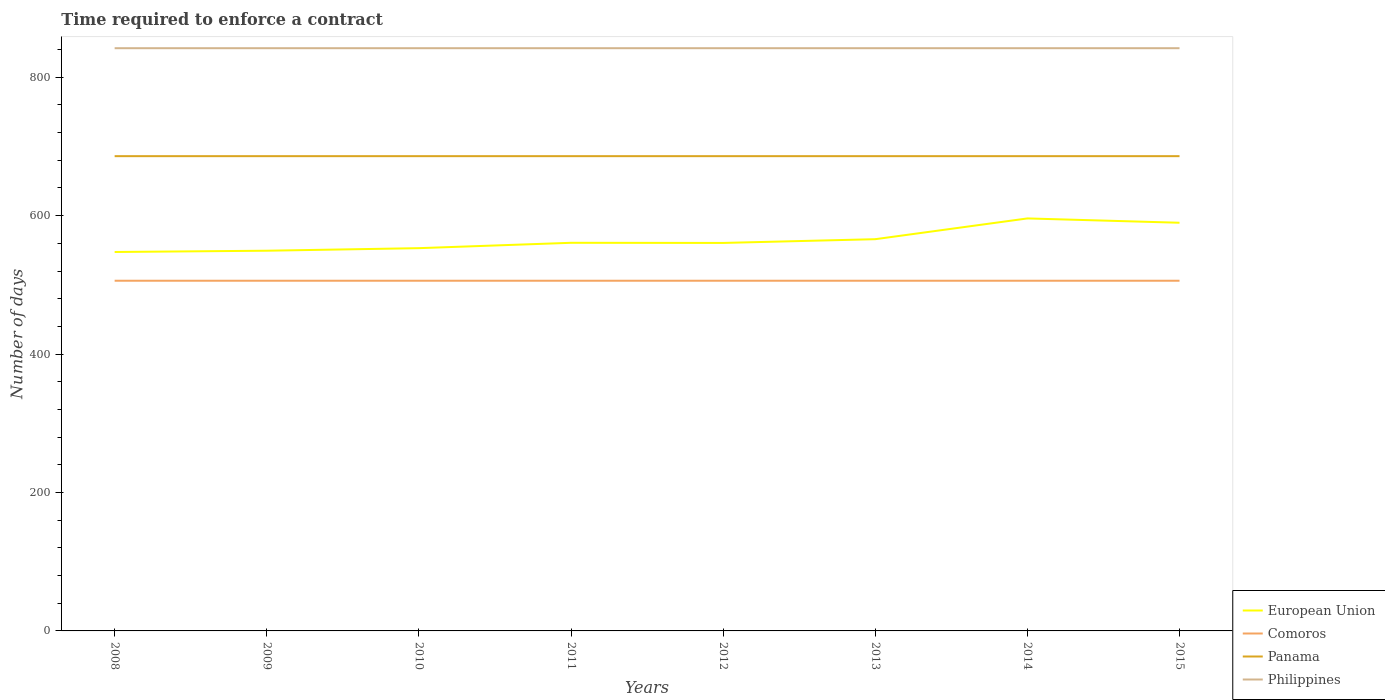Is the number of lines equal to the number of legend labels?
Your answer should be very brief. Yes. Across all years, what is the maximum number of days required to enforce a contract in Philippines?
Your answer should be very brief. 842. What is the total number of days required to enforce a contract in Panama in the graph?
Provide a short and direct response. 0. How many years are there in the graph?
Your answer should be very brief. 8. What is the difference between two consecutive major ticks on the Y-axis?
Ensure brevity in your answer.  200. Are the values on the major ticks of Y-axis written in scientific E-notation?
Ensure brevity in your answer.  No. Where does the legend appear in the graph?
Make the answer very short. Bottom right. How many legend labels are there?
Give a very brief answer. 4. How are the legend labels stacked?
Provide a succinct answer. Vertical. What is the title of the graph?
Provide a succinct answer. Time required to enforce a contract. What is the label or title of the X-axis?
Your response must be concise. Years. What is the label or title of the Y-axis?
Provide a succinct answer. Number of days. What is the Number of days of European Union in 2008?
Your answer should be compact. 547.56. What is the Number of days in Comoros in 2008?
Keep it short and to the point. 506. What is the Number of days in Panama in 2008?
Give a very brief answer. 686. What is the Number of days of Philippines in 2008?
Provide a succinct answer. 842. What is the Number of days of European Union in 2009?
Make the answer very short. 549.37. What is the Number of days of Comoros in 2009?
Your answer should be compact. 506. What is the Number of days in Panama in 2009?
Your response must be concise. 686. What is the Number of days in Philippines in 2009?
Your answer should be very brief. 842. What is the Number of days in European Union in 2010?
Offer a very short reply. 553.07. What is the Number of days in Comoros in 2010?
Offer a very short reply. 506. What is the Number of days in Panama in 2010?
Keep it short and to the point. 686. What is the Number of days of Philippines in 2010?
Your response must be concise. 842. What is the Number of days in European Union in 2011?
Your answer should be very brief. 560.82. What is the Number of days in Comoros in 2011?
Provide a short and direct response. 506. What is the Number of days in Panama in 2011?
Your answer should be very brief. 686. What is the Number of days in Philippines in 2011?
Make the answer very short. 842. What is the Number of days in European Union in 2012?
Offer a terse response. 560.61. What is the Number of days of Comoros in 2012?
Ensure brevity in your answer.  506. What is the Number of days in Panama in 2012?
Offer a very short reply. 686. What is the Number of days in Philippines in 2012?
Make the answer very short. 842. What is the Number of days of European Union in 2013?
Keep it short and to the point. 566.04. What is the Number of days of Comoros in 2013?
Your answer should be very brief. 506. What is the Number of days of Panama in 2013?
Provide a short and direct response. 686. What is the Number of days of Philippines in 2013?
Make the answer very short. 842. What is the Number of days of European Union in 2014?
Offer a terse response. 596.04. What is the Number of days of Comoros in 2014?
Offer a terse response. 506. What is the Number of days in Panama in 2014?
Keep it short and to the point. 686. What is the Number of days in Philippines in 2014?
Keep it short and to the point. 842. What is the Number of days of European Union in 2015?
Your answer should be very brief. 589.79. What is the Number of days in Comoros in 2015?
Give a very brief answer. 506. What is the Number of days of Panama in 2015?
Give a very brief answer. 686. What is the Number of days in Philippines in 2015?
Offer a very short reply. 842. Across all years, what is the maximum Number of days of European Union?
Offer a terse response. 596.04. Across all years, what is the maximum Number of days in Comoros?
Give a very brief answer. 506. Across all years, what is the maximum Number of days in Panama?
Your answer should be very brief. 686. Across all years, what is the maximum Number of days in Philippines?
Keep it short and to the point. 842. Across all years, what is the minimum Number of days in European Union?
Make the answer very short. 547.56. Across all years, what is the minimum Number of days in Comoros?
Offer a very short reply. 506. Across all years, what is the minimum Number of days in Panama?
Your answer should be compact. 686. Across all years, what is the minimum Number of days in Philippines?
Make the answer very short. 842. What is the total Number of days of European Union in the graph?
Provide a succinct answer. 4523.29. What is the total Number of days of Comoros in the graph?
Your answer should be very brief. 4048. What is the total Number of days of Panama in the graph?
Your answer should be compact. 5488. What is the total Number of days of Philippines in the graph?
Make the answer very short. 6736. What is the difference between the Number of days in European Union in 2008 and that in 2009?
Your answer should be very brief. -1.81. What is the difference between the Number of days in Philippines in 2008 and that in 2009?
Offer a very short reply. 0. What is the difference between the Number of days in European Union in 2008 and that in 2010?
Offer a very short reply. -5.52. What is the difference between the Number of days of Comoros in 2008 and that in 2010?
Make the answer very short. 0. What is the difference between the Number of days of European Union in 2008 and that in 2011?
Ensure brevity in your answer.  -13.27. What is the difference between the Number of days of Panama in 2008 and that in 2011?
Give a very brief answer. 0. What is the difference between the Number of days in Philippines in 2008 and that in 2011?
Your answer should be very brief. 0. What is the difference between the Number of days of European Union in 2008 and that in 2012?
Make the answer very short. -13.05. What is the difference between the Number of days in Panama in 2008 and that in 2012?
Keep it short and to the point. 0. What is the difference between the Number of days of Philippines in 2008 and that in 2012?
Provide a short and direct response. 0. What is the difference between the Number of days of European Union in 2008 and that in 2013?
Provide a short and direct response. -18.48. What is the difference between the Number of days in Comoros in 2008 and that in 2013?
Your response must be concise. 0. What is the difference between the Number of days of Panama in 2008 and that in 2013?
Your answer should be compact. 0. What is the difference between the Number of days of Philippines in 2008 and that in 2013?
Give a very brief answer. 0. What is the difference between the Number of days of European Union in 2008 and that in 2014?
Your answer should be compact. -48.48. What is the difference between the Number of days of Panama in 2008 and that in 2014?
Ensure brevity in your answer.  0. What is the difference between the Number of days in European Union in 2008 and that in 2015?
Provide a short and direct response. -42.23. What is the difference between the Number of days of Comoros in 2008 and that in 2015?
Your answer should be very brief. 0. What is the difference between the Number of days in Panama in 2008 and that in 2015?
Your answer should be very brief. 0. What is the difference between the Number of days in European Union in 2009 and that in 2010?
Ensure brevity in your answer.  -3.7. What is the difference between the Number of days in Panama in 2009 and that in 2010?
Provide a succinct answer. 0. What is the difference between the Number of days of European Union in 2009 and that in 2011?
Your answer should be very brief. -11.45. What is the difference between the Number of days in Comoros in 2009 and that in 2011?
Keep it short and to the point. 0. What is the difference between the Number of days of Panama in 2009 and that in 2011?
Provide a succinct answer. 0. What is the difference between the Number of days in European Union in 2009 and that in 2012?
Keep it short and to the point. -11.24. What is the difference between the Number of days of Comoros in 2009 and that in 2012?
Offer a terse response. 0. What is the difference between the Number of days in European Union in 2009 and that in 2013?
Your response must be concise. -16.67. What is the difference between the Number of days of Comoros in 2009 and that in 2013?
Offer a terse response. 0. What is the difference between the Number of days in Philippines in 2009 and that in 2013?
Your answer should be compact. 0. What is the difference between the Number of days of European Union in 2009 and that in 2014?
Offer a very short reply. -46.67. What is the difference between the Number of days in Comoros in 2009 and that in 2014?
Provide a short and direct response. 0. What is the difference between the Number of days of Philippines in 2009 and that in 2014?
Offer a terse response. 0. What is the difference between the Number of days of European Union in 2009 and that in 2015?
Ensure brevity in your answer.  -40.42. What is the difference between the Number of days in Comoros in 2009 and that in 2015?
Ensure brevity in your answer.  0. What is the difference between the Number of days of Panama in 2009 and that in 2015?
Your answer should be compact. 0. What is the difference between the Number of days in Philippines in 2009 and that in 2015?
Keep it short and to the point. 0. What is the difference between the Number of days of European Union in 2010 and that in 2011?
Make the answer very short. -7.75. What is the difference between the Number of days of Panama in 2010 and that in 2011?
Provide a short and direct response. 0. What is the difference between the Number of days in Philippines in 2010 and that in 2011?
Offer a terse response. 0. What is the difference between the Number of days in European Union in 2010 and that in 2012?
Provide a short and direct response. -7.53. What is the difference between the Number of days in Panama in 2010 and that in 2012?
Ensure brevity in your answer.  0. What is the difference between the Number of days in European Union in 2010 and that in 2013?
Your response must be concise. -12.96. What is the difference between the Number of days in European Union in 2010 and that in 2014?
Offer a very short reply. -42.96. What is the difference between the Number of days in Comoros in 2010 and that in 2014?
Provide a short and direct response. 0. What is the difference between the Number of days of Panama in 2010 and that in 2014?
Ensure brevity in your answer.  0. What is the difference between the Number of days of European Union in 2010 and that in 2015?
Offer a terse response. -36.71. What is the difference between the Number of days of Comoros in 2010 and that in 2015?
Your answer should be very brief. 0. What is the difference between the Number of days in Panama in 2010 and that in 2015?
Make the answer very short. 0. What is the difference between the Number of days in Philippines in 2010 and that in 2015?
Provide a succinct answer. 0. What is the difference between the Number of days in European Union in 2011 and that in 2012?
Provide a short and direct response. 0.21. What is the difference between the Number of days of Comoros in 2011 and that in 2012?
Give a very brief answer. 0. What is the difference between the Number of days in Panama in 2011 and that in 2012?
Your answer should be compact. 0. What is the difference between the Number of days of Philippines in 2011 and that in 2012?
Provide a short and direct response. 0. What is the difference between the Number of days of European Union in 2011 and that in 2013?
Provide a short and direct response. -5.21. What is the difference between the Number of days in Comoros in 2011 and that in 2013?
Offer a terse response. 0. What is the difference between the Number of days in Panama in 2011 and that in 2013?
Ensure brevity in your answer.  0. What is the difference between the Number of days of European Union in 2011 and that in 2014?
Your response must be concise. -35.21. What is the difference between the Number of days in Panama in 2011 and that in 2014?
Give a very brief answer. 0. What is the difference between the Number of days in Philippines in 2011 and that in 2014?
Your answer should be very brief. 0. What is the difference between the Number of days in European Union in 2011 and that in 2015?
Offer a terse response. -28.96. What is the difference between the Number of days in Comoros in 2011 and that in 2015?
Provide a short and direct response. 0. What is the difference between the Number of days of European Union in 2012 and that in 2013?
Give a very brief answer. -5.43. What is the difference between the Number of days in Comoros in 2012 and that in 2013?
Ensure brevity in your answer.  0. What is the difference between the Number of days in European Union in 2012 and that in 2014?
Your answer should be compact. -35.43. What is the difference between the Number of days of Panama in 2012 and that in 2014?
Offer a very short reply. 0. What is the difference between the Number of days in European Union in 2012 and that in 2015?
Provide a short and direct response. -29.18. What is the difference between the Number of days of European Union in 2013 and that in 2015?
Your response must be concise. -23.75. What is the difference between the Number of days in Comoros in 2013 and that in 2015?
Your answer should be very brief. 0. What is the difference between the Number of days in European Union in 2014 and that in 2015?
Ensure brevity in your answer.  6.25. What is the difference between the Number of days of Comoros in 2014 and that in 2015?
Your answer should be very brief. 0. What is the difference between the Number of days in European Union in 2008 and the Number of days in Comoros in 2009?
Your answer should be compact. 41.56. What is the difference between the Number of days of European Union in 2008 and the Number of days of Panama in 2009?
Your response must be concise. -138.44. What is the difference between the Number of days of European Union in 2008 and the Number of days of Philippines in 2009?
Provide a short and direct response. -294.44. What is the difference between the Number of days in Comoros in 2008 and the Number of days in Panama in 2009?
Ensure brevity in your answer.  -180. What is the difference between the Number of days of Comoros in 2008 and the Number of days of Philippines in 2009?
Your response must be concise. -336. What is the difference between the Number of days of Panama in 2008 and the Number of days of Philippines in 2009?
Your response must be concise. -156. What is the difference between the Number of days of European Union in 2008 and the Number of days of Comoros in 2010?
Your answer should be very brief. 41.56. What is the difference between the Number of days in European Union in 2008 and the Number of days in Panama in 2010?
Your response must be concise. -138.44. What is the difference between the Number of days in European Union in 2008 and the Number of days in Philippines in 2010?
Provide a succinct answer. -294.44. What is the difference between the Number of days of Comoros in 2008 and the Number of days of Panama in 2010?
Ensure brevity in your answer.  -180. What is the difference between the Number of days of Comoros in 2008 and the Number of days of Philippines in 2010?
Keep it short and to the point. -336. What is the difference between the Number of days of Panama in 2008 and the Number of days of Philippines in 2010?
Keep it short and to the point. -156. What is the difference between the Number of days in European Union in 2008 and the Number of days in Comoros in 2011?
Provide a short and direct response. 41.56. What is the difference between the Number of days in European Union in 2008 and the Number of days in Panama in 2011?
Provide a short and direct response. -138.44. What is the difference between the Number of days of European Union in 2008 and the Number of days of Philippines in 2011?
Your response must be concise. -294.44. What is the difference between the Number of days of Comoros in 2008 and the Number of days of Panama in 2011?
Your answer should be compact. -180. What is the difference between the Number of days of Comoros in 2008 and the Number of days of Philippines in 2011?
Provide a short and direct response. -336. What is the difference between the Number of days in Panama in 2008 and the Number of days in Philippines in 2011?
Provide a succinct answer. -156. What is the difference between the Number of days in European Union in 2008 and the Number of days in Comoros in 2012?
Keep it short and to the point. 41.56. What is the difference between the Number of days of European Union in 2008 and the Number of days of Panama in 2012?
Give a very brief answer. -138.44. What is the difference between the Number of days in European Union in 2008 and the Number of days in Philippines in 2012?
Provide a succinct answer. -294.44. What is the difference between the Number of days in Comoros in 2008 and the Number of days in Panama in 2012?
Offer a very short reply. -180. What is the difference between the Number of days in Comoros in 2008 and the Number of days in Philippines in 2012?
Offer a terse response. -336. What is the difference between the Number of days in Panama in 2008 and the Number of days in Philippines in 2012?
Provide a short and direct response. -156. What is the difference between the Number of days in European Union in 2008 and the Number of days in Comoros in 2013?
Your answer should be very brief. 41.56. What is the difference between the Number of days of European Union in 2008 and the Number of days of Panama in 2013?
Your response must be concise. -138.44. What is the difference between the Number of days of European Union in 2008 and the Number of days of Philippines in 2013?
Ensure brevity in your answer.  -294.44. What is the difference between the Number of days in Comoros in 2008 and the Number of days in Panama in 2013?
Your answer should be compact. -180. What is the difference between the Number of days in Comoros in 2008 and the Number of days in Philippines in 2013?
Provide a succinct answer. -336. What is the difference between the Number of days of Panama in 2008 and the Number of days of Philippines in 2013?
Your response must be concise. -156. What is the difference between the Number of days of European Union in 2008 and the Number of days of Comoros in 2014?
Keep it short and to the point. 41.56. What is the difference between the Number of days of European Union in 2008 and the Number of days of Panama in 2014?
Ensure brevity in your answer.  -138.44. What is the difference between the Number of days of European Union in 2008 and the Number of days of Philippines in 2014?
Your response must be concise. -294.44. What is the difference between the Number of days of Comoros in 2008 and the Number of days of Panama in 2014?
Give a very brief answer. -180. What is the difference between the Number of days in Comoros in 2008 and the Number of days in Philippines in 2014?
Provide a succinct answer. -336. What is the difference between the Number of days in Panama in 2008 and the Number of days in Philippines in 2014?
Your answer should be compact. -156. What is the difference between the Number of days of European Union in 2008 and the Number of days of Comoros in 2015?
Provide a short and direct response. 41.56. What is the difference between the Number of days in European Union in 2008 and the Number of days in Panama in 2015?
Your answer should be very brief. -138.44. What is the difference between the Number of days in European Union in 2008 and the Number of days in Philippines in 2015?
Make the answer very short. -294.44. What is the difference between the Number of days in Comoros in 2008 and the Number of days in Panama in 2015?
Your answer should be compact. -180. What is the difference between the Number of days of Comoros in 2008 and the Number of days of Philippines in 2015?
Keep it short and to the point. -336. What is the difference between the Number of days in Panama in 2008 and the Number of days in Philippines in 2015?
Ensure brevity in your answer.  -156. What is the difference between the Number of days in European Union in 2009 and the Number of days in Comoros in 2010?
Provide a short and direct response. 43.37. What is the difference between the Number of days of European Union in 2009 and the Number of days of Panama in 2010?
Offer a terse response. -136.63. What is the difference between the Number of days of European Union in 2009 and the Number of days of Philippines in 2010?
Your response must be concise. -292.63. What is the difference between the Number of days of Comoros in 2009 and the Number of days of Panama in 2010?
Your response must be concise. -180. What is the difference between the Number of days of Comoros in 2009 and the Number of days of Philippines in 2010?
Ensure brevity in your answer.  -336. What is the difference between the Number of days of Panama in 2009 and the Number of days of Philippines in 2010?
Provide a short and direct response. -156. What is the difference between the Number of days in European Union in 2009 and the Number of days in Comoros in 2011?
Your answer should be very brief. 43.37. What is the difference between the Number of days in European Union in 2009 and the Number of days in Panama in 2011?
Offer a terse response. -136.63. What is the difference between the Number of days in European Union in 2009 and the Number of days in Philippines in 2011?
Provide a succinct answer. -292.63. What is the difference between the Number of days of Comoros in 2009 and the Number of days of Panama in 2011?
Provide a short and direct response. -180. What is the difference between the Number of days of Comoros in 2009 and the Number of days of Philippines in 2011?
Your answer should be compact. -336. What is the difference between the Number of days of Panama in 2009 and the Number of days of Philippines in 2011?
Offer a terse response. -156. What is the difference between the Number of days in European Union in 2009 and the Number of days in Comoros in 2012?
Your response must be concise. 43.37. What is the difference between the Number of days in European Union in 2009 and the Number of days in Panama in 2012?
Make the answer very short. -136.63. What is the difference between the Number of days in European Union in 2009 and the Number of days in Philippines in 2012?
Provide a short and direct response. -292.63. What is the difference between the Number of days of Comoros in 2009 and the Number of days of Panama in 2012?
Keep it short and to the point. -180. What is the difference between the Number of days of Comoros in 2009 and the Number of days of Philippines in 2012?
Provide a short and direct response. -336. What is the difference between the Number of days of Panama in 2009 and the Number of days of Philippines in 2012?
Give a very brief answer. -156. What is the difference between the Number of days of European Union in 2009 and the Number of days of Comoros in 2013?
Keep it short and to the point. 43.37. What is the difference between the Number of days in European Union in 2009 and the Number of days in Panama in 2013?
Ensure brevity in your answer.  -136.63. What is the difference between the Number of days of European Union in 2009 and the Number of days of Philippines in 2013?
Your response must be concise. -292.63. What is the difference between the Number of days in Comoros in 2009 and the Number of days in Panama in 2013?
Your answer should be compact. -180. What is the difference between the Number of days of Comoros in 2009 and the Number of days of Philippines in 2013?
Your answer should be very brief. -336. What is the difference between the Number of days of Panama in 2009 and the Number of days of Philippines in 2013?
Your answer should be compact. -156. What is the difference between the Number of days in European Union in 2009 and the Number of days in Comoros in 2014?
Make the answer very short. 43.37. What is the difference between the Number of days in European Union in 2009 and the Number of days in Panama in 2014?
Your response must be concise. -136.63. What is the difference between the Number of days of European Union in 2009 and the Number of days of Philippines in 2014?
Your response must be concise. -292.63. What is the difference between the Number of days in Comoros in 2009 and the Number of days in Panama in 2014?
Ensure brevity in your answer.  -180. What is the difference between the Number of days in Comoros in 2009 and the Number of days in Philippines in 2014?
Offer a very short reply. -336. What is the difference between the Number of days in Panama in 2009 and the Number of days in Philippines in 2014?
Offer a very short reply. -156. What is the difference between the Number of days of European Union in 2009 and the Number of days of Comoros in 2015?
Your response must be concise. 43.37. What is the difference between the Number of days of European Union in 2009 and the Number of days of Panama in 2015?
Make the answer very short. -136.63. What is the difference between the Number of days of European Union in 2009 and the Number of days of Philippines in 2015?
Offer a very short reply. -292.63. What is the difference between the Number of days in Comoros in 2009 and the Number of days in Panama in 2015?
Ensure brevity in your answer.  -180. What is the difference between the Number of days of Comoros in 2009 and the Number of days of Philippines in 2015?
Give a very brief answer. -336. What is the difference between the Number of days in Panama in 2009 and the Number of days in Philippines in 2015?
Provide a succinct answer. -156. What is the difference between the Number of days of European Union in 2010 and the Number of days of Comoros in 2011?
Your response must be concise. 47.07. What is the difference between the Number of days of European Union in 2010 and the Number of days of Panama in 2011?
Keep it short and to the point. -132.93. What is the difference between the Number of days in European Union in 2010 and the Number of days in Philippines in 2011?
Your answer should be very brief. -288.93. What is the difference between the Number of days of Comoros in 2010 and the Number of days of Panama in 2011?
Give a very brief answer. -180. What is the difference between the Number of days in Comoros in 2010 and the Number of days in Philippines in 2011?
Your response must be concise. -336. What is the difference between the Number of days in Panama in 2010 and the Number of days in Philippines in 2011?
Your answer should be very brief. -156. What is the difference between the Number of days in European Union in 2010 and the Number of days in Comoros in 2012?
Your answer should be very brief. 47.07. What is the difference between the Number of days in European Union in 2010 and the Number of days in Panama in 2012?
Give a very brief answer. -132.93. What is the difference between the Number of days of European Union in 2010 and the Number of days of Philippines in 2012?
Give a very brief answer. -288.93. What is the difference between the Number of days in Comoros in 2010 and the Number of days in Panama in 2012?
Your response must be concise. -180. What is the difference between the Number of days of Comoros in 2010 and the Number of days of Philippines in 2012?
Offer a very short reply. -336. What is the difference between the Number of days of Panama in 2010 and the Number of days of Philippines in 2012?
Provide a succinct answer. -156. What is the difference between the Number of days of European Union in 2010 and the Number of days of Comoros in 2013?
Provide a short and direct response. 47.07. What is the difference between the Number of days in European Union in 2010 and the Number of days in Panama in 2013?
Offer a terse response. -132.93. What is the difference between the Number of days in European Union in 2010 and the Number of days in Philippines in 2013?
Make the answer very short. -288.93. What is the difference between the Number of days of Comoros in 2010 and the Number of days of Panama in 2013?
Give a very brief answer. -180. What is the difference between the Number of days of Comoros in 2010 and the Number of days of Philippines in 2013?
Your response must be concise. -336. What is the difference between the Number of days of Panama in 2010 and the Number of days of Philippines in 2013?
Ensure brevity in your answer.  -156. What is the difference between the Number of days of European Union in 2010 and the Number of days of Comoros in 2014?
Offer a terse response. 47.07. What is the difference between the Number of days of European Union in 2010 and the Number of days of Panama in 2014?
Offer a terse response. -132.93. What is the difference between the Number of days of European Union in 2010 and the Number of days of Philippines in 2014?
Make the answer very short. -288.93. What is the difference between the Number of days of Comoros in 2010 and the Number of days of Panama in 2014?
Offer a very short reply. -180. What is the difference between the Number of days of Comoros in 2010 and the Number of days of Philippines in 2014?
Offer a very short reply. -336. What is the difference between the Number of days of Panama in 2010 and the Number of days of Philippines in 2014?
Your answer should be compact. -156. What is the difference between the Number of days of European Union in 2010 and the Number of days of Comoros in 2015?
Your answer should be very brief. 47.07. What is the difference between the Number of days in European Union in 2010 and the Number of days in Panama in 2015?
Offer a very short reply. -132.93. What is the difference between the Number of days of European Union in 2010 and the Number of days of Philippines in 2015?
Ensure brevity in your answer.  -288.93. What is the difference between the Number of days of Comoros in 2010 and the Number of days of Panama in 2015?
Your answer should be compact. -180. What is the difference between the Number of days of Comoros in 2010 and the Number of days of Philippines in 2015?
Provide a short and direct response. -336. What is the difference between the Number of days in Panama in 2010 and the Number of days in Philippines in 2015?
Provide a succinct answer. -156. What is the difference between the Number of days in European Union in 2011 and the Number of days in Comoros in 2012?
Provide a short and direct response. 54.82. What is the difference between the Number of days in European Union in 2011 and the Number of days in Panama in 2012?
Ensure brevity in your answer.  -125.18. What is the difference between the Number of days in European Union in 2011 and the Number of days in Philippines in 2012?
Offer a very short reply. -281.18. What is the difference between the Number of days of Comoros in 2011 and the Number of days of Panama in 2012?
Offer a very short reply. -180. What is the difference between the Number of days in Comoros in 2011 and the Number of days in Philippines in 2012?
Provide a succinct answer. -336. What is the difference between the Number of days in Panama in 2011 and the Number of days in Philippines in 2012?
Ensure brevity in your answer.  -156. What is the difference between the Number of days in European Union in 2011 and the Number of days in Comoros in 2013?
Your answer should be very brief. 54.82. What is the difference between the Number of days of European Union in 2011 and the Number of days of Panama in 2013?
Your response must be concise. -125.18. What is the difference between the Number of days of European Union in 2011 and the Number of days of Philippines in 2013?
Ensure brevity in your answer.  -281.18. What is the difference between the Number of days of Comoros in 2011 and the Number of days of Panama in 2013?
Your response must be concise. -180. What is the difference between the Number of days of Comoros in 2011 and the Number of days of Philippines in 2013?
Your response must be concise. -336. What is the difference between the Number of days in Panama in 2011 and the Number of days in Philippines in 2013?
Provide a succinct answer. -156. What is the difference between the Number of days in European Union in 2011 and the Number of days in Comoros in 2014?
Provide a succinct answer. 54.82. What is the difference between the Number of days of European Union in 2011 and the Number of days of Panama in 2014?
Provide a succinct answer. -125.18. What is the difference between the Number of days of European Union in 2011 and the Number of days of Philippines in 2014?
Offer a very short reply. -281.18. What is the difference between the Number of days in Comoros in 2011 and the Number of days in Panama in 2014?
Your response must be concise. -180. What is the difference between the Number of days of Comoros in 2011 and the Number of days of Philippines in 2014?
Offer a terse response. -336. What is the difference between the Number of days in Panama in 2011 and the Number of days in Philippines in 2014?
Offer a terse response. -156. What is the difference between the Number of days in European Union in 2011 and the Number of days in Comoros in 2015?
Ensure brevity in your answer.  54.82. What is the difference between the Number of days of European Union in 2011 and the Number of days of Panama in 2015?
Your answer should be compact. -125.18. What is the difference between the Number of days of European Union in 2011 and the Number of days of Philippines in 2015?
Your answer should be very brief. -281.18. What is the difference between the Number of days of Comoros in 2011 and the Number of days of Panama in 2015?
Your response must be concise. -180. What is the difference between the Number of days in Comoros in 2011 and the Number of days in Philippines in 2015?
Ensure brevity in your answer.  -336. What is the difference between the Number of days of Panama in 2011 and the Number of days of Philippines in 2015?
Offer a terse response. -156. What is the difference between the Number of days of European Union in 2012 and the Number of days of Comoros in 2013?
Your response must be concise. 54.61. What is the difference between the Number of days of European Union in 2012 and the Number of days of Panama in 2013?
Ensure brevity in your answer.  -125.39. What is the difference between the Number of days in European Union in 2012 and the Number of days in Philippines in 2013?
Provide a short and direct response. -281.39. What is the difference between the Number of days in Comoros in 2012 and the Number of days in Panama in 2013?
Your response must be concise. -180. What is the difference between the Number of days of Comoros in 2012 and the Number of days of Philippines in 2013?
Ensure brevity in your answer.  -336. What is the difference between the Number of days in Panama in 2012 and the Number of days in Philippines in 2013?
Make the answer very short. -156. What is the difference between the Number of days of European Union in 2012 and the Number of days of Comoros in 2014?
Ensure brevity in your answer.  54.61. What is the difference between the Number of days in European Union in 2012 and the Number of days in Panama in 2014?
Provide a short and direct response. -125.39. What is the difference between the Number of days of European Union in 2012 and the Number of days of Philippines in 2014?
Keep it short and to the point. -281.39. What is the difference between the Number of days of Comoros in 2012 and the Number of days of Panama in 2014?
Provide a short and direct response. -180. What is the difference between the Number of days of Comoros in 2012 and the Number of days of Philippines in 2014?
Keep it short and to the point. -336. What is the difference between the Number of days in Panama in 2012 and the Number of days in Philippines in 2014?
Your answer should be compact. -156. What is the difference between the Number of days in European Union in 2012 and the Number of days in Comoros in 2015?
Give a very brief answer. 54.61. What is the difference between the Number of days in European Union in 2012 and the Number of days in Panama in 2015?
Give a very brief answer. -125.39. What is the difference between the Number of days of European Union in 2012 and the Number of days of Philippines in 2015?
Give a very brief answer. -281.39. What is the difference between the Number of days of Comoros in 2012 and the Number of days of Panama in 2015?
Ensure brevity in your answer.  -180. What is the difference between the Number of days in Comoros in 2012 and the Number of days in Philippines in 2015?
Provide a succinct answer. -336. What is the difference between the Number of days of Panama in 2012 and the Number of days of Philippines in 2015?
Offer a terse response. -156. What is the difference between the Number of days of European Union in 2013 and the Number of days of Comoros in 2014?
Keep it short and to the point. 60.04. What is the difference between the Number of days in European Union in 2013 and the Number of days in Panama in 2014?
Give a very brief answer. -119.96. What is the difference between the Number of days in European Union in 2013 and the Number of days in Philippines in 2014?
Ensure brevity in your answer.  -275.96. What is the difference between the Number of days in Comoros in 2013 and the Number of days in Panama in 2014?
Ensure brevity in your answer.  -180. What is the difference between the Number of days in Comoros in 2013 and the Number of days in Philippines in 2014?
Offer a very short reply. -336. What is the difference between the Number of days in Panama in 2013 and the Number of days in Philippines in 2014?
Keep it short and to the point. -156. What is the difference between the Number of days in European Union in 2013 and the Number of days in Comoros in 2015?
Provide a succinct answer. 60.04. What is the difference between the Number of days in European Union in 2013 and the Number of days in Panama in 2015?
Offer a terse response. -119.96. What is the difference between the Number of days of European Union in 2013 and the Number of days of Philippines in 2015?
Offer a terse response. -275.96. What is the difference between the Number of days in Comoros in 2013 and the Number of days in Panama in 2015?
Your response must be concise. -180. What is the difference between the Number of days in Comoros in 2013 and the Number of days in Philippines in 2015?
Your answer should be compact. -336. What is the difference between the Number of days of Panama in 2013 and the Number of days of Philippines in 2015?
Offer a terse response. -156. What is the difference between the Number of days in European Union in 2014 and the Number of days in Comoros in 2015?
Provide a short and direct response. 90.04. What is the difference between the Number of days in European Union in 2014 and the Number of days in Panama in 2015?
Make the answer very short. -89.96. What is the difference between the Number of days of European Union in 2014 and the Number of days of Philippines in 2015?
Offer a terse response. -245.96. What is the difference between the Number of days in Comoros in 2014 and the Number of days in Panama in 2015?
Your answer should be very brief. -180. What is the difference between the Number of days in Comoros in 2014 and the Number of days in Philippines in 2015?
Provide a short and direct response. -336. What is the difference between the Number of days in Panama in 2014 and the Number of days in Philippines in 2015?
Offer a very short reply. -156. What is the average Number of days in European Union per year?
Provide a succinct answer. 565.41. What is the average Number of days in Comoros per year?
Provide a short and direct response. 506. What is the average Number of days of Panama per year?
Provide a short and direct response. 686. What is the average Number of days of Philippines per year?
Offer a terse response. 842. In the year 2008, what is the difference between the Number of days of European Union and Number of days of Comoros?
Provide a short and direct response. 41.56. In the year 2008, what is the difference between the Number of days in European Union and Number of days in Panama?
Offer a very short reply. -138.44. In the year 2008, what is the difference between the Number of days of European Union and Number of days of Philippines?
Your answer should be very brief. -294.44. In the year 2008, what is the difference between the Number of days of Comoros and Number of days of Panama?
Provide a short and direct response. -180. In the year 2008, what is the difference between the Number of days of Comoros and Number of days of Philippines?
Provide a succinct answer. -336. In the year 2008, what is the difference between the Number of days of Panama and Number of days of Philippines?
Provide a short and direct response. -156. In the year 2009, what is the difference between the Number of days in European Union and Number of days in Comoros?
Your answer should be compact. 43.37. In the year 2009, what is the difference between the Number of days in European Union and Number of days in Panama?
Your answer should be compact. -136.63. In the year 2009, what is the difference between the Number of days of European Union and Number of days of Philippines?
Give a very brief answer. -292.63. In the year 2009, what is the difference between the Number of days of Comoros and Number of days of Panama?
Your answer should be very brief. -180. In the year 2009, what is the difference between the Number of days in Comoros and Number of days in Philippines?
Give a very brief answer. -336. In the year 2009, what is the difference between the Number of days in Panama and Number of days in Philippines?
Offer a very short reply. -156. In the year 2010, what is the difference between the Number of days of European Union and Number of days of Comoros?
Give a very brief answer. 47.07. In the year 2010, what is the difference between the Number of days in European Union and Number of days in Panama?
Your answer should be compact. -132.93. In the year 2010, what is the difference between the Number of days in European Union and Number of days in Philippines?
Your answer should be very brief. -288.93. In the year 2010, what is the difference between the Number of days of Comoros and Number of days of Panama?
Ensure brevity in your answer.  -180. In the year 2010, what is the difference between the Number of days of Comoros and Number of days of Philippines?
Offer a very short reply. -336. In the year 2010, what is the difference between the Number of days of Panama and Number of days of Philippines?
Give a very brief answer. -156. In the year 2011, what is the difference between the Number of days of European Union and Number of days of Comoros?
Keep it short and to the point. 54.82. In the year 2011, what is the difference between the Number of days in European Union and Number of days in Panama?
Give a very brief answer. -125.18. In the year 2011, what is the difference between the Number of days in European Union and Number of days in Philippines?
Offer a very short reply. -281.18. In the year 2011, what is the difference between the Number of days of Comoros and Number of days of Panama?
Provide a short and direct response. -180. In the year 2011, what is the difference between the Number of days in Comoros and Number of days in Philippines?
Give a very brief answer. -336. In the year 2011, what is the difference between the Number of days in Panama and Number of days in Philippines?
Ensure brevity in your answer.  -156. In the year 2012, what is the difference between the Number of days of European Union and Number of days of Comoros?
Offer a very short reply. 54.61. In the year 2012, what is the difference between the Number of days in European Union and Number of days in Panama?
Your answer should be very brief. -125.39. In the year 2012, what is the difference between the Number of days of European Union and Number of days of Philippines?
Give a very brief answer. -281.39. In the year 2012, what is the difference between the Number of days in Comoros and Number of days in Panama?
Offer a terse response. -180. In the year 2012, what is the difference between the Number of days of Comoros and Number of days of Philippines?
Ensure brevity in your answer.  -336. In the year 2012, what is the difference between the Number of days of Panama and Number of days of Philippines?
Give a very brief answer. -156. In the year 2013, what is the difference between the Number of days of European Union and Number of days of Comoros?
Your response must be concise. 60.04. In the year 2013, what is the difference between the Number of days of European Union and Number of days of Panama?
Ensure brevity in your answer.  -119.96. In the year 2013, what is the difference between the Number of days of European Union and Number of days of Philippines?
Make the answer very short. -275.96. In the year 2013, what is the difference between the Number of days in Comoros and Number of days in Panama?
Provide a succinct answer. -180. In the year 2013, what is the difference between the Number of days of Comoros and Number of days of Philippines?
Provide a short and direct response. -336. In the year 2013, what is the difference between the Number of days in Panama and Number of days in Philippines?
Give a very brief answer. -156. In the year 2014, what is the difference between the Number of days of European Union and Number of days of Comoros?
Provide a succinct answer. 90.04. In the year 2014, what is the difference between the Number of days in European Union and Number of days in Panama?
Offer a very short reply. -89.96. In the year 2014, what is the difference between the Number of days of European Union and Number of days of Philippines?
Ensure brevity in your answer.  -245.96. In the year 2014, what is the difference between the Number of days of Comoros and Number of days of Panama?
Ensure brevity in your answer.  -180. In the year 2014, what is the difference between the Number of days of Comoros and Number of days of Philippines?
Your answer should be compact. -336. In the year 2014, what is the difference between the Number of days of Panama and Number of days of Philippines?
Ensure brevity in your answer.  -156. In the year 2015, what is the difference between the Number of days in European Union and Number of days in Comoros?
Provide a short and direct response. 83.79. In the year 2015, what is the difference between the Number of days of European Union and Number of days of Panama?
Offer a terse response. -96.21. In the year 2015, what is the difference between the Number of days in European Union and Number of days in Philippines?
Provide a succinct answer. -252.21. In the year 2015, what is the difference between the Number of days in Comoros and Number of days in Panama?
Ensure brevity in your answer.  -180. In the year 2015, what is the difference between the Number of days of Comoros and Number of days of Philippines?
Your answer should be very brief. -336. In the year 2015, what is the difference between the Number of days in Panama and Number of days in Philippines?
Make the answer very short. -156. What is the ratio of the Number of days in European Union in 2008 to that in 2009?
Keep it short and to the point. 1. What is the ratio of the Number of days in Comoros in 2008 to that in 2009?
Offer a terse response. 1. What is the ratio of the Number of days in Panama in 2008 to that in 2009?
Offer a terse response. 1. What is the ratio of the Number of days of European Union in 2008 to that in 2010?
Give a very brief answer. 0.99. What is the ratio of the Number of days of Comoros in 2008 to that in 2010?
Make the answer very short. 1. What is the ratio of the Number of days of Panama in 2008 to that in 2010?
Ensure brevity in your answer.  1. What is the ratio of the Number of days in European Union in 2008 to that in 2011?
Offer a very short reply. 0.98. What is the ratio of the Number of days in Philippines in 2008 to that in 2011?
Your answer should be very brief. 1. What is the ratio of the Number of days in European Union in 2008 to that in 2012?
Keep it short and to the point. 0.98. What is the ratio of the Number of days in Comoros in 2008 to that in 2012?
Your response must be concise. 1. What is the ratio of the Number of days of Panama in 2008 to that in 2012?
Provide a succinct answer. 1. What is the ratio of the Number of days in Philippines in 2008 to that in 2012?
Make the answer very short. 1. What is the ratio of the Number of days of European Union in 2008 to that in 2013?
Your answer should be very brief. 0.97. What is the ratio of the Number of days in Panama in 2008 to that in 2013?
Offer a very short reply. 1. What is the ratio of the Number of days in Philippines in 2008 to that in 2013?
Provide a succinct answer. 1. What is the ratio of the Number of days of European Union in 2008 to that in 2014?
Give a very brief answer. 0.92. What is the ratio of the Number of days in Comoros in 2008 to that in 2014?
Your answer should be compact. 1. What is the ratio of the Number of days of Panama in 2008 to that in 2014?
Your answer should be compact. 1. What is the ratio of the Number of days of Philippines in 2008 to that in 2014?
Your answer should be compact. 1. What is the ratio of the Number of days of European Union in 2008 to that in 2015?
Provide a short and direct response. 0.93. What is the ratio of the Number of days of Comoros in 2009 to that in 2010?
Keep it short and to the point. 1. What is the ratio of the Number of days in Panama in 2009 to that in 2010?
Make the answer very short. 1. What is the ratio of the Number of days of Philippines in 2009 to that in 2010?
Provide a succinct answer. 1. What is the ratio of the Number of days of European Union in 2009 to that in 2011?
Give a very brief answer. 0.98. What is the ratio of the Number of days of European Union in 2009 to that in 2012?
Your answer should be compact. 0.98. What is the ratio of the Number of days in Comoros in 2009 to that in 2012?
Make the answer very short. 1. What is the ratio of the Number of days of Panama in 2009 to that in 2012?
Keep it short and to the point. 1. What is the ratio of the Number of days of European Union in 2009 to that in 2013?
Offer a very short reply. 0.97. What is the ratio of the Number of days of Philippines in 2009 to that in 2013?
Keep it short and to the point. 1. What is the ratio of the Number of days in European Union in 2009 to that in 2014?
Ensure brevity in your answer.  0.92. What is the ratio of the Number of days in Panama in 2009 to that in 2014?
Give a very brief answer. 1. What is the ratio of the Number of days in European Union in 2009 to that in 2015?
Your answer should be very brief. 0.93. What is the ratio of the Number of days in Comoros in 2009 to that in 2015?
Offer a terse response. 1. What is the ratio of the Number of days of Panama in 2009 to that in 2015?
Your response must be concise. 1. What is the ratio of the Number of days of European Union in 2010 to that in 2011?
Ensure brevity in your answer.  0.99. What is the ratio of the Number of days in Panama in 2010 to that in 2011?
Ensure brevity in your answer.  1. What is the ratio of the Number of days in European Union in 2010 to that in 2012?
Keep it short and to the point. 0.99. What is the ratio of the Number of days in Comoros in 2010 to that in 2012?
Your answer should be compact. 1. What is the ratio of the Number of days of Panama in 2010 to that in 2012?
Offer a very short reply. 1. What is the ratio of the Number of days in European Union in 2010 to that in 2013?
Your answer should be compact. 0.98. What is the ratio of the Number of days in Panama in 2010 to that in 2013?
Your answer should be compact. 1. What is the ratio of the Number of days of Philippines in 2010 to that in 2013?
Your response must be concise. 1. What is the ratio of the Number of days in European Union in 2010 to that in 2014?
Your answer should be compact. 0.93. What is the ratio of the Number of days in Panama in 2010 to that in 2014?
Provide a short and direct response. 1. What is the ratio of the Number of days in European Union in 2010 to that in 2015?
Give a very brief answer. 0.94. What is the ratio of the Number of days of Panama in 2010 to that in 2015?
Give a very brief answer. 1. What is the ratio of the Number of days in European Union in 2011 to that in 2012?
Offer a terse response. 1. What is the ratio of the Number of days of Comoros in 2011 to that in 2012?
Offer a terse response. 1. What is the ratio of the Number of days of Panama in 2011 to that in 2012?
Give a very brief answer. 1. What is the ratio of the Number of days in Philippines in 2011 to that in 2012?
Your answer should be compact. 1. What is the ratio of the Number of days of Comoros in 2011 to that in 2013?
Provide a succinct answer. 1. What is the ratio of the Number of days of Panama in 2011 to that in 2013?
Make the answer very short. 1. What is the ratio of the Number of days in Philippines in 2011 to that in 2013?
Give a very brief answer. 1. What is the ratio of the Number of days in European Union in 2011 to that in 2014?
Your answer should be compact. 0.94. What is the ratio of the Number of days of Comoros in 2011 to that in 2014?
Your answer should be very brief. 1. What is the ratio of the Number of days in European Union in 2011 to that in 2015?
Make the answer very short. 0.95. What is the ratio of the Number of days in Panama in 2011 to that in 2015?
Ensure brevity in your answer.  1. What is the ratio of the Number of days of Philippines in 2011 to that in 2015?
Your answer should be very brief. 1. What is the ratio of the Number of days in European Union in 2012 to that in 2013?
Your answer should be very brief. 0.99. What is the ratio of the Number of days in European Union in 2012 to that in 2014?
Your response must be concise. 0.94. What is the ratio of the Number of days in Comoros in 2012 to that in 2014?
Keep it short and to the point. 1. What is the ratio of the Number of days of Panama in 2012 to that in 2014?
Ensure brevity in your answer.  1. What is the ratio of the Number of days in Philippines in 2012 to that in 2014?
Provide a short and direct response. 1. What is the ratio of the Number of days of European Union in 2012 to that in 2015?
Give a very brief answer. 0.95. What is the ratio of the Number of days in Comoros in 2012 to that in 2015?
Provide a short and direct response. 1. What is the ratio of the Number of days of Panama in 2012 to that in 2015?
Provide a succinct answer. 1. What is the ratio of the Number of days in European Union in 2013 to that in 2014?
Give a very brief answer. 0.95. What is the ratio of the Number of days of Comoros in 2013 to that in 2014?
Keep it short and to the point. 1. What is the ratio of the Number of days of Panama in 2013 to that in 2014?
Offer a very short reply. 1. What is the ratio of the Number of days of European Union in 2013 to that in 2015?
Your answer should be very brief. 0.96. What is the ratio of the Number of days in European Union in 2014 to that in 2015?
Keep it short and to the point. 1.01. What is the ratio of the Number of days in Philippines in 2014 to that in 2015?
Offer a terse response. 1. What is the difference between the highest and the second highest Number of days of European Union?
Give a very brief answer. 6.25. What is the difference between the highest and the second highest Number of days in Comoros?
Your answer should be very brief. 0. What is the difference between the highest and the lowest Number of days of European Union?
Provide a short and direct response. 48.48. What is the difference between the highest and the lowest Number of days of Comoros?
Your answer should be compact. 0. What is the difference between the highest and the lowest Number of days of Philippines?
Your response must be concise. 0. 